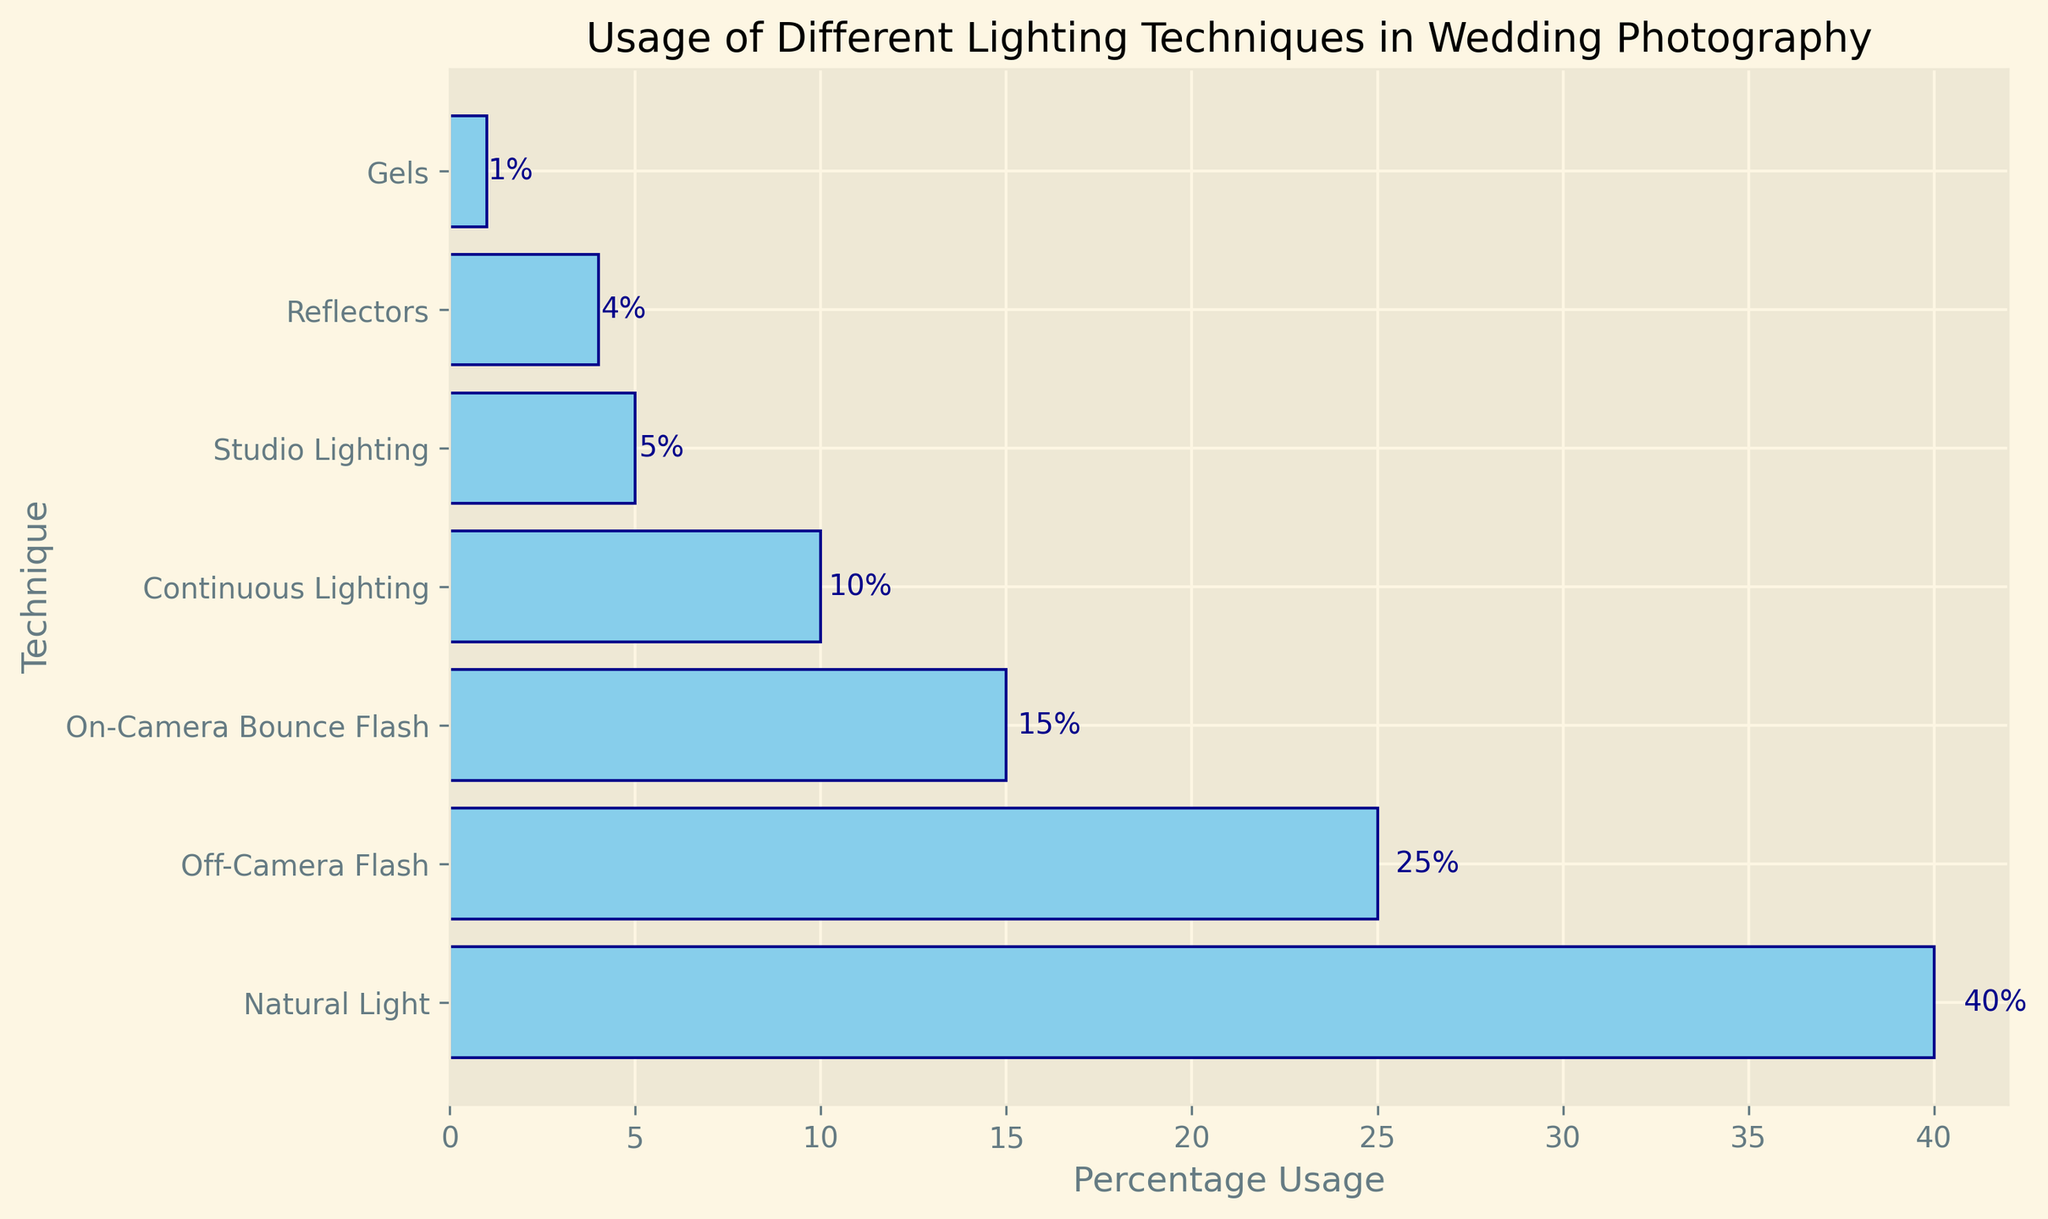What's the most commonly used lighting technique in wedding photography? The bar chart shows the percentage usage of each lighting technique. The tallest bar represents Natural Light with 40%, which is the highest percentage among all techniques.
Answer: Natural Light Which lighting technique is used more: Off-Camera Flash or Continuous Lighting? Observing the lengths of the bars, Off-Camera Flash has a longer bar (25%) than Continuous Lighting (10%).
Answer: Off-Camera Flash What is the combined percentage usage of On-Camera Bounce Flash, Continuous Lighting, and Studio Lighting? Summing up the percentages of the three techniques: On-Camera Bounce Flash (15%) + Continuous Lighting (10%) + Studio Lighting (5%) = 30%.
Answer: 30% Is Reflectors usage more or less than Gels? The bar representing Reflectors shows 4%, while the bar for Gels shows 1%. Since 4% is greater than 1%, Reflectors usage is more.
Answer: More Are there any lighting techniques used by less than 5% of photographers? If so, which ones? The chart shows Reflectors at 4% and Gels at 1%, both of which are employed by less than 5% of photographers.
Answer: Reflectors, Gels What is the difference in usage percentage between Natural Light and On-Camera Bounce Flash? The percentages for Natural Light and On-Camera Bounce Flash are 40% and 15%, respectively, so the difference is 40% - 15% = 25%.
Answer: 25% Which two lighting techniques have the closest percentage usage? Examining the differences between all pairs, the smallest difference is between Continuous Lighting (10%) and Studio Lighting (5%), with a difference of 5%.
Answer: Continuous Lighting, Studio Lighting If Natural Light and Off-Camera Flash are combined, what percentage of photographers use this combined technique? Adding the percentages of Natural Light (40%) and Off-Camera Flash (25%), we get a total of 40% + 25% = 65%.
Answer: 65% Which technique has the lowest usage and by what percentage? The shortest bar represents Gels with a percentage usage of 1%. Hence, Gels have the lowest usage.
Answer: Gels, 1% 